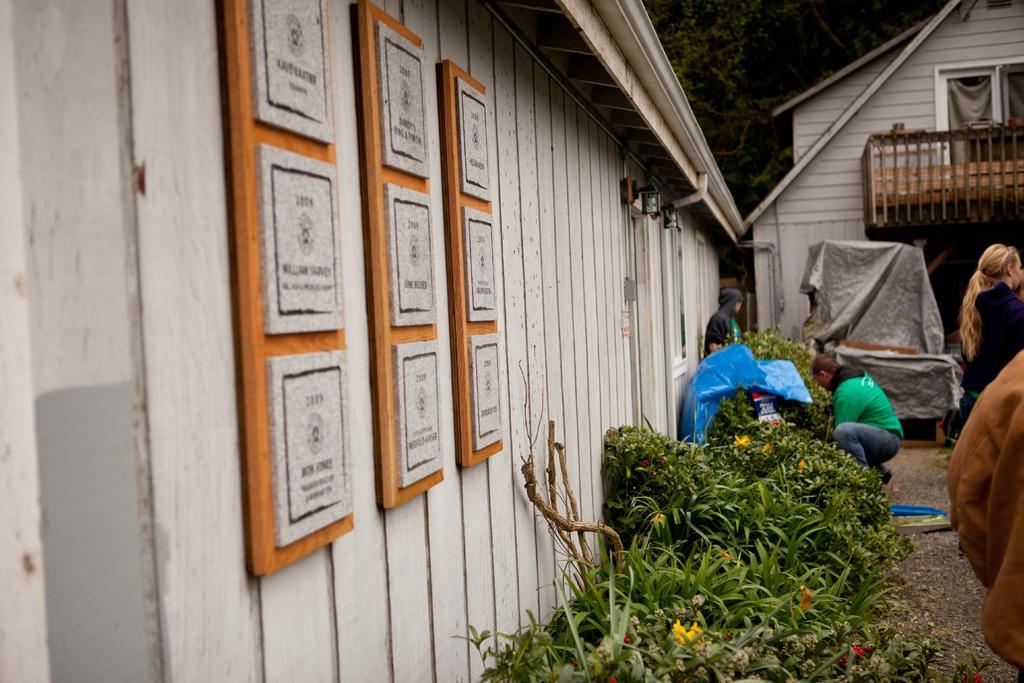Describe this image in one or two sentences. As we can see in the image there are buildings, plants, few people and in the background there are trees. 